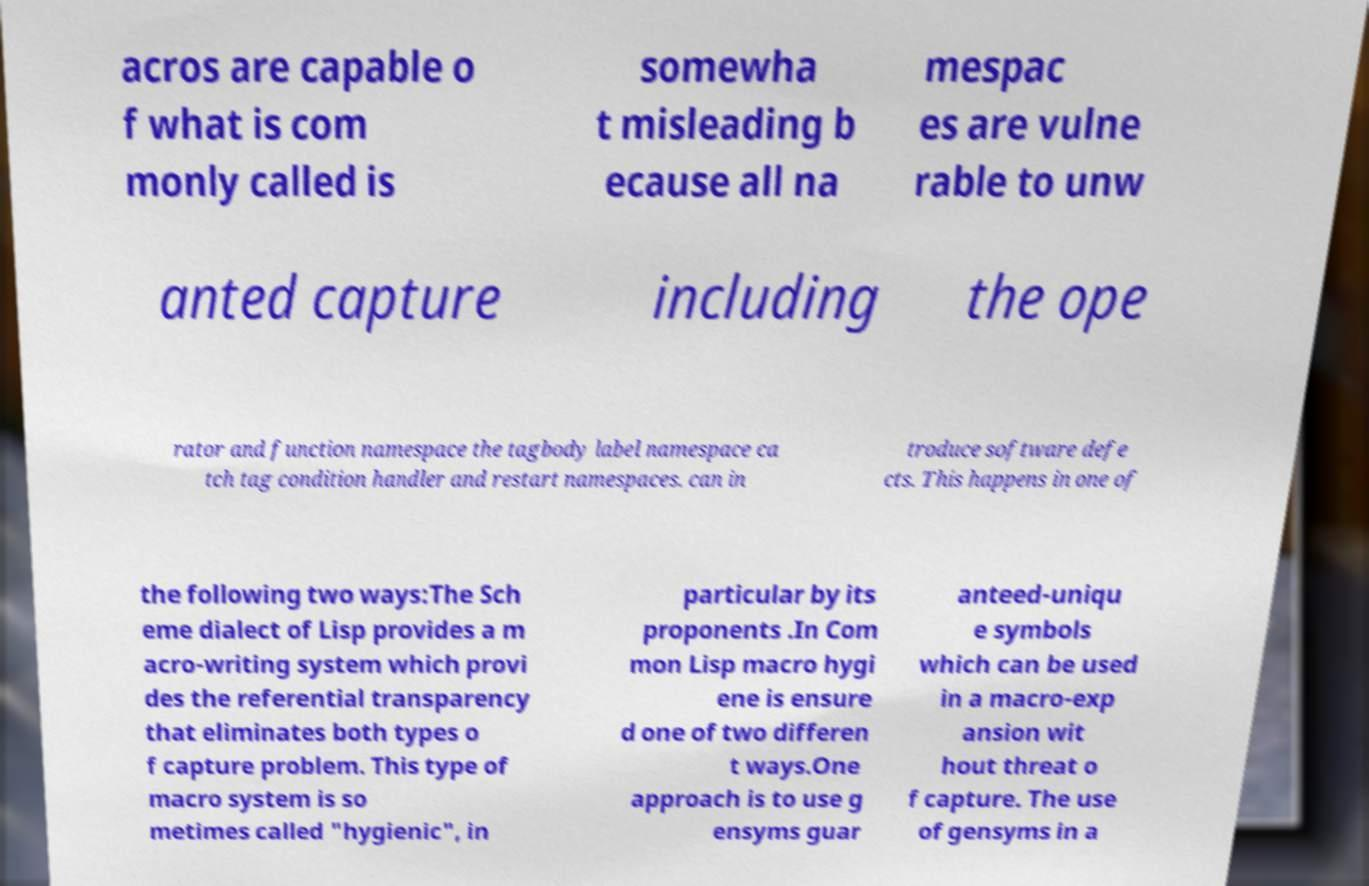For documentation purposes, I need the text within this image transcribed. Could you provide that? acros are capable o f what is com monly called is somewha t misleading b ecause all na mespac es are vulne rable to unw anted capture including the ope rator and function namespace the tagbody label namespace ca tch tag condition handler and restart namespaces. can in troduce software defe cts. This happens in one of the following two ways:The Sch eme dialect of Lisp provides a m acro-writing system which provi des the referential transparency that eliminates both types o f capture problem. This type of macro system is so metimes called "hygienic", in particular by its proponents .In Com mon Lisp macro hygi ene is ensure d one of two differen t ways.One approach is to use g ensyms guar anteed-uniqu e symbols which can be used in a macro-exp ansion wit hout threat o f capture. The use of gensyms in a 